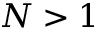<formula> <loc_0><loc_0><loc_500><loc_500>N > 1</formula> 